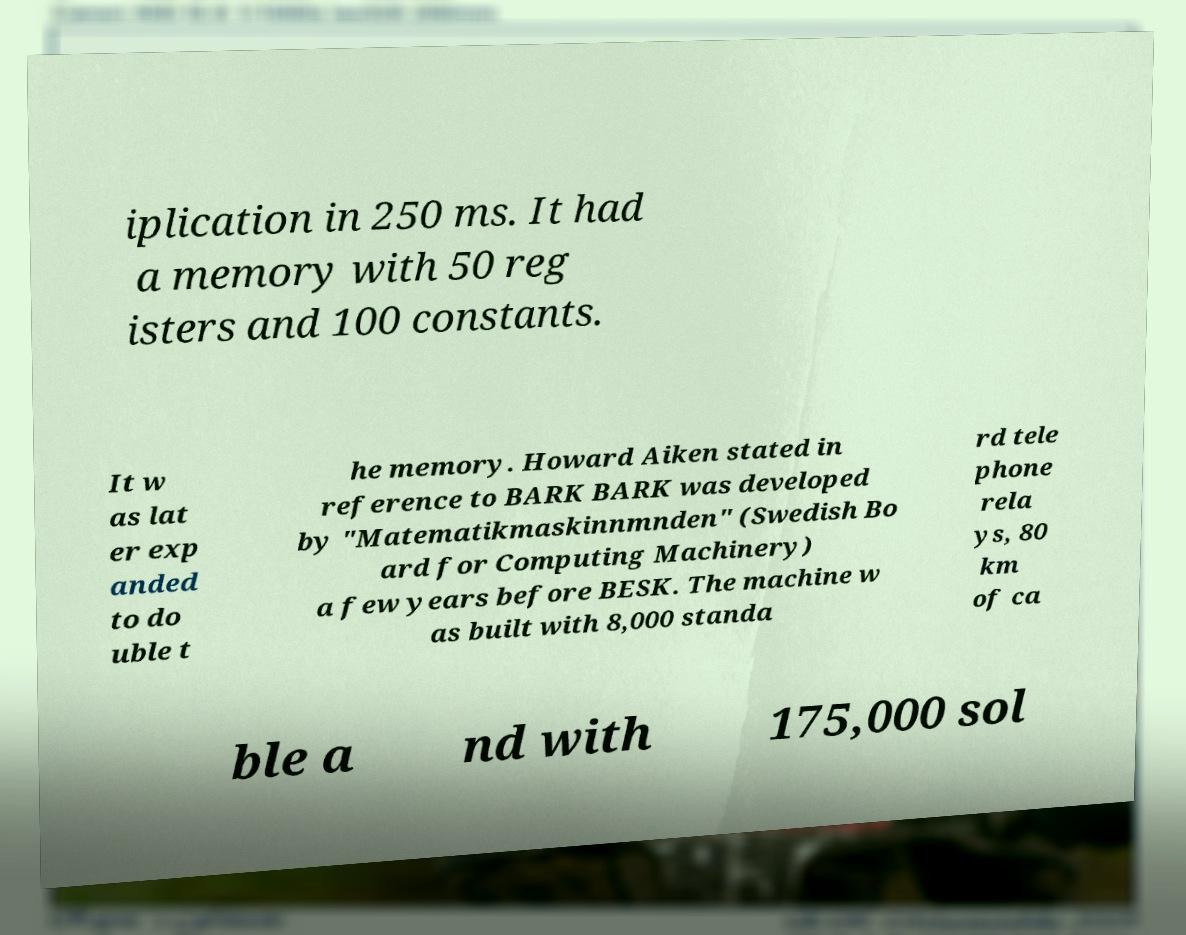I need the written content from this picture converted into text. Can you do that? iplication in 250 ms. It had a memory with 50 reg isters and 100 constants. It w as lat er exp anded to do uble t he memory. Howard Aiken stated in reference to BARK BARK was developed by "Matematikmaskinnmnden" (Swedish Bo ard for Computing Machinery) a few years before BESK. The machine w as built with 8,000 standa rd tele phone rela ys, 80 km of ca ble a nd with 175,000 sol 